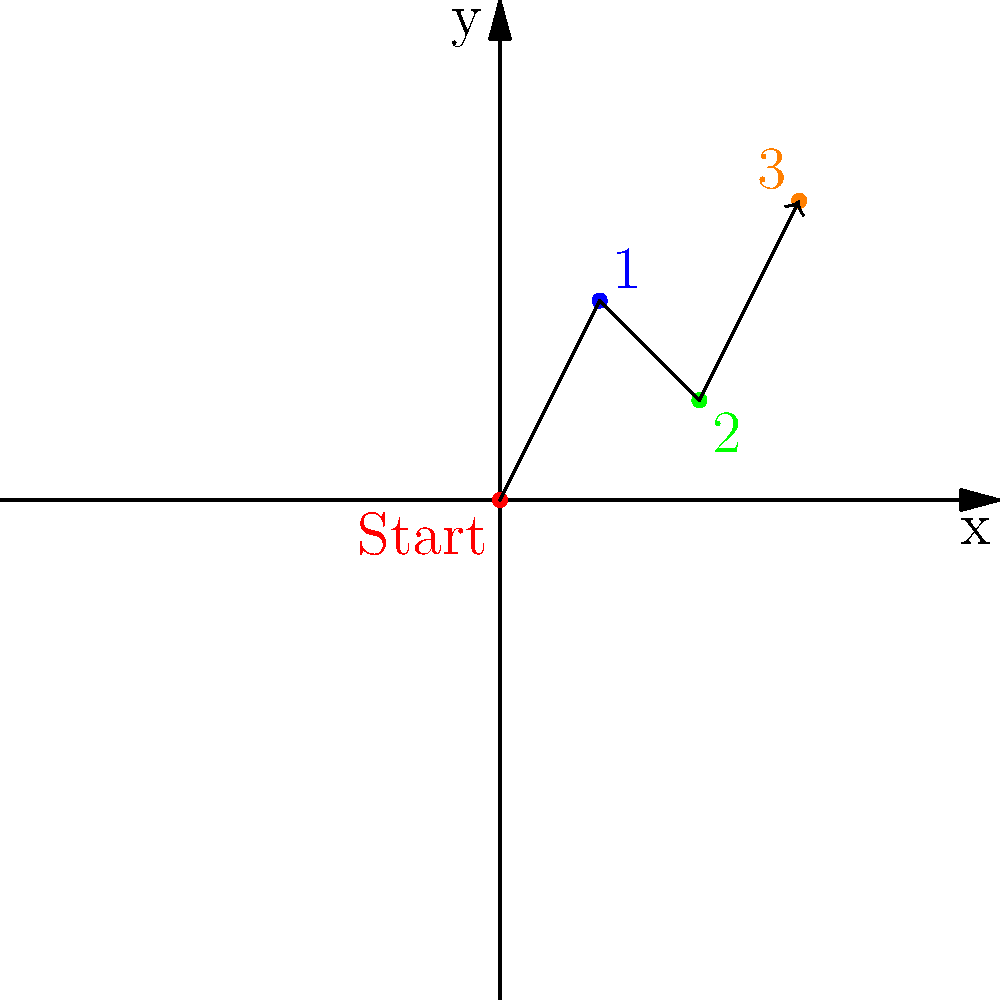In a salsa dance routine, your steps are plotted on a coordinate plane. Starting at the origin (0,0), you move to (1,2), then to (2,1), and finally to (3,3). What is the total distance traveled in this dance sequence, rounded to the nearest tenth? Let's break this down step-by-step:

1) We need to calculate the distance between each pair of consecutive points and then sum these distances.

2) Distance formula: $d = \sqrt{(x_2-x_1)^2 + (y_2-y_1)^2}$

3) First move: (0,0) to (1,2)
   $d_1 = \sqrt{(1-0)^2 + (2-0)^2} = \sqrt{1 + 4} = \sqrt{5} \approx 2.236$

4) Second move: (1,2) to (2,1)
   $d_2 = \sqrt{(2-1)^2 + (1-2)^2} = \sqrt{1 + 1} = \sqrt{2} \approx 1.414$

5) Third move: (2,1) to (3,3)
   $d_3 = \sqrt{(3-2)^2 + (3-1)^2} = \sqrt{1 + 4} = \sqrt{5} \approx 2.236$

6) Total distance: $d_{total} = d_1 + d_2 + d_3 \approx 2.236 + 1.414 + 2.236 = 5.886$

7) Rounding to the nearest tenth: 5.9
Answer: 5.9 units 